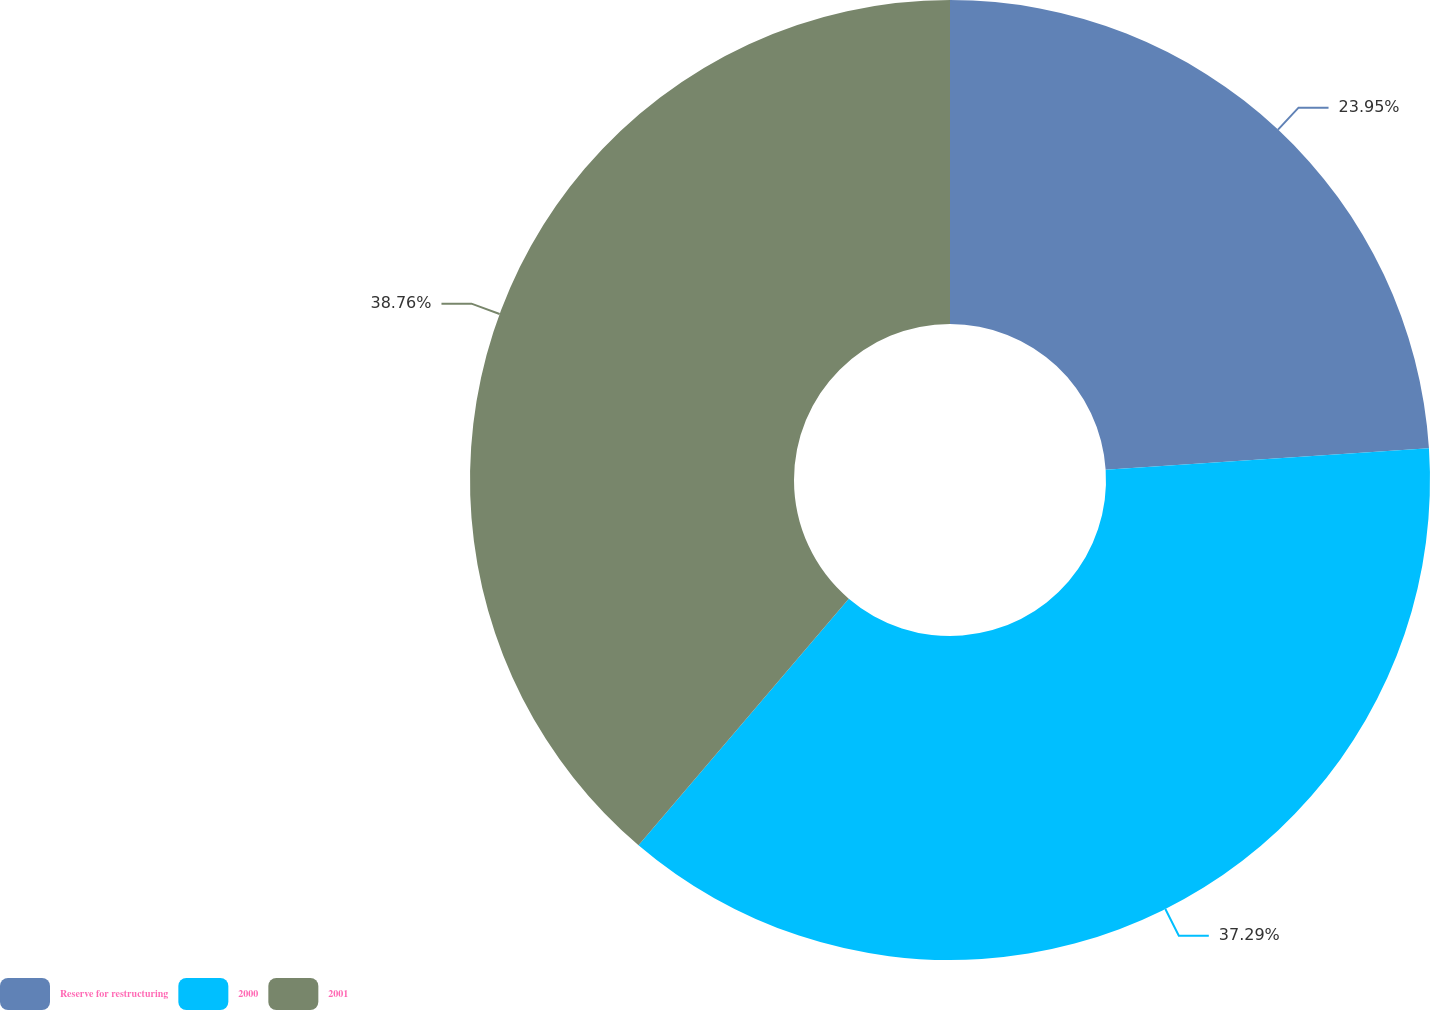Convert chart to OTSL. <chart><loc_0><loc_0><loc_500><loc_500><pie_chart><fcel>Reserve for restructuring<fcel>2000<fcel>2001<nl><fcel>23.95%<fcel>37.29%<fcel>38.76%<nl></chart> 